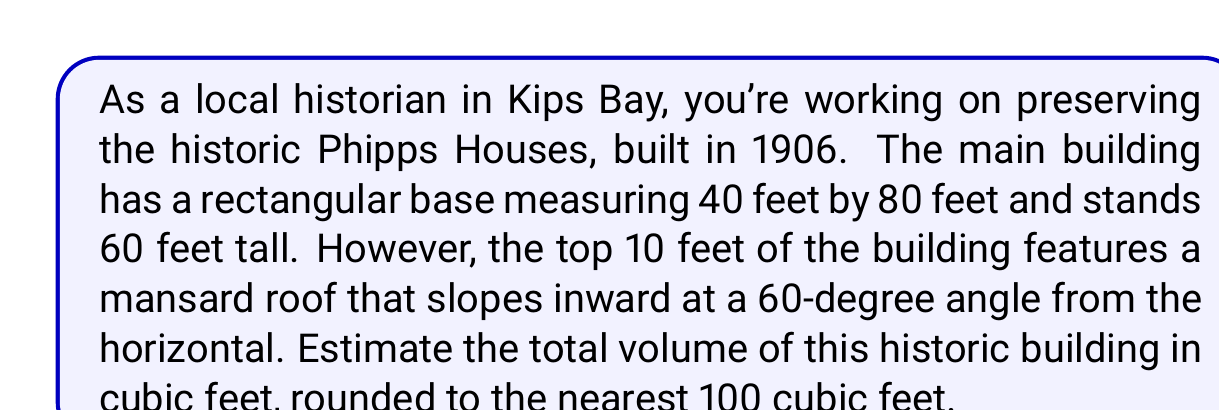Teach me how to tackle this problem. Let's approach this problem step-by-step:

1) First, we need to calculate the volume of the main rectangular portion of the building:
   $$V_{rectangle} = length \times width \times height$$
   $$V_{rectangle} = 80 \text{ ft} \times 40 \text{ ft} \times 50 \text{ ft} = 160,000 \text{ ft}^3$$

2) Now, we need to calculate the volume of the mansard roof portion. This is essentially a truncated rectangular pyramid. We can calculate this using the formula:
   $$V_{truncated} = \frac{h}{3}(A_1 + A_2 + \sqrt{A_1A_2})$$
   where $h$ is the height, $A_1$ is the area of the base, and $A_2$ is the area of the top.

3) We know $A_1 = 80 \text{ ft} \times 40 \text{ ft} = 3,200 \text{ ft}^2$

4) To find $A_2$, we need to calculate how much the roof slopes inward:
   The slope is 60° from horizontal, so it's 30° from vertical.
   In a right triangle with hypotenuse 10 ft (height of mansard roof):
   $$\text{Inward slope} = 10 \times \tan(30°) \approx 5.77 \text{ ft}$$

5) So the top dimensions are reduced by about 5.77 ft on each side:
   $$A_2 = (80 - 2 \times 5.77) \times (40 - 2 \times 5.77) \approx 2,053.4 \text{ ft}^2$$

6) Now we can calculate the volume of the mansard roof:
   $$V_{mansard} = \frac{10}{3}(3200 + 2053.4 + \sqrt{3200 \times 2053.4}) \approx 24,345 \text{ ft}^3$$

7) The total volume is the sum of both parts:
   $$V_{total} = V_{rectangle} + V_{mansard} = 160,000 + 24,345 = 184,345 \text{ ft}^3$$

8) Rounding to the nearest 100 cubic feet:
   $$V_{total} \approx 184,300 \text{ ft}^3$$
Answer: The estimated volume of the historic Phipps Houses building is approximately 184,300 cubic feet. 